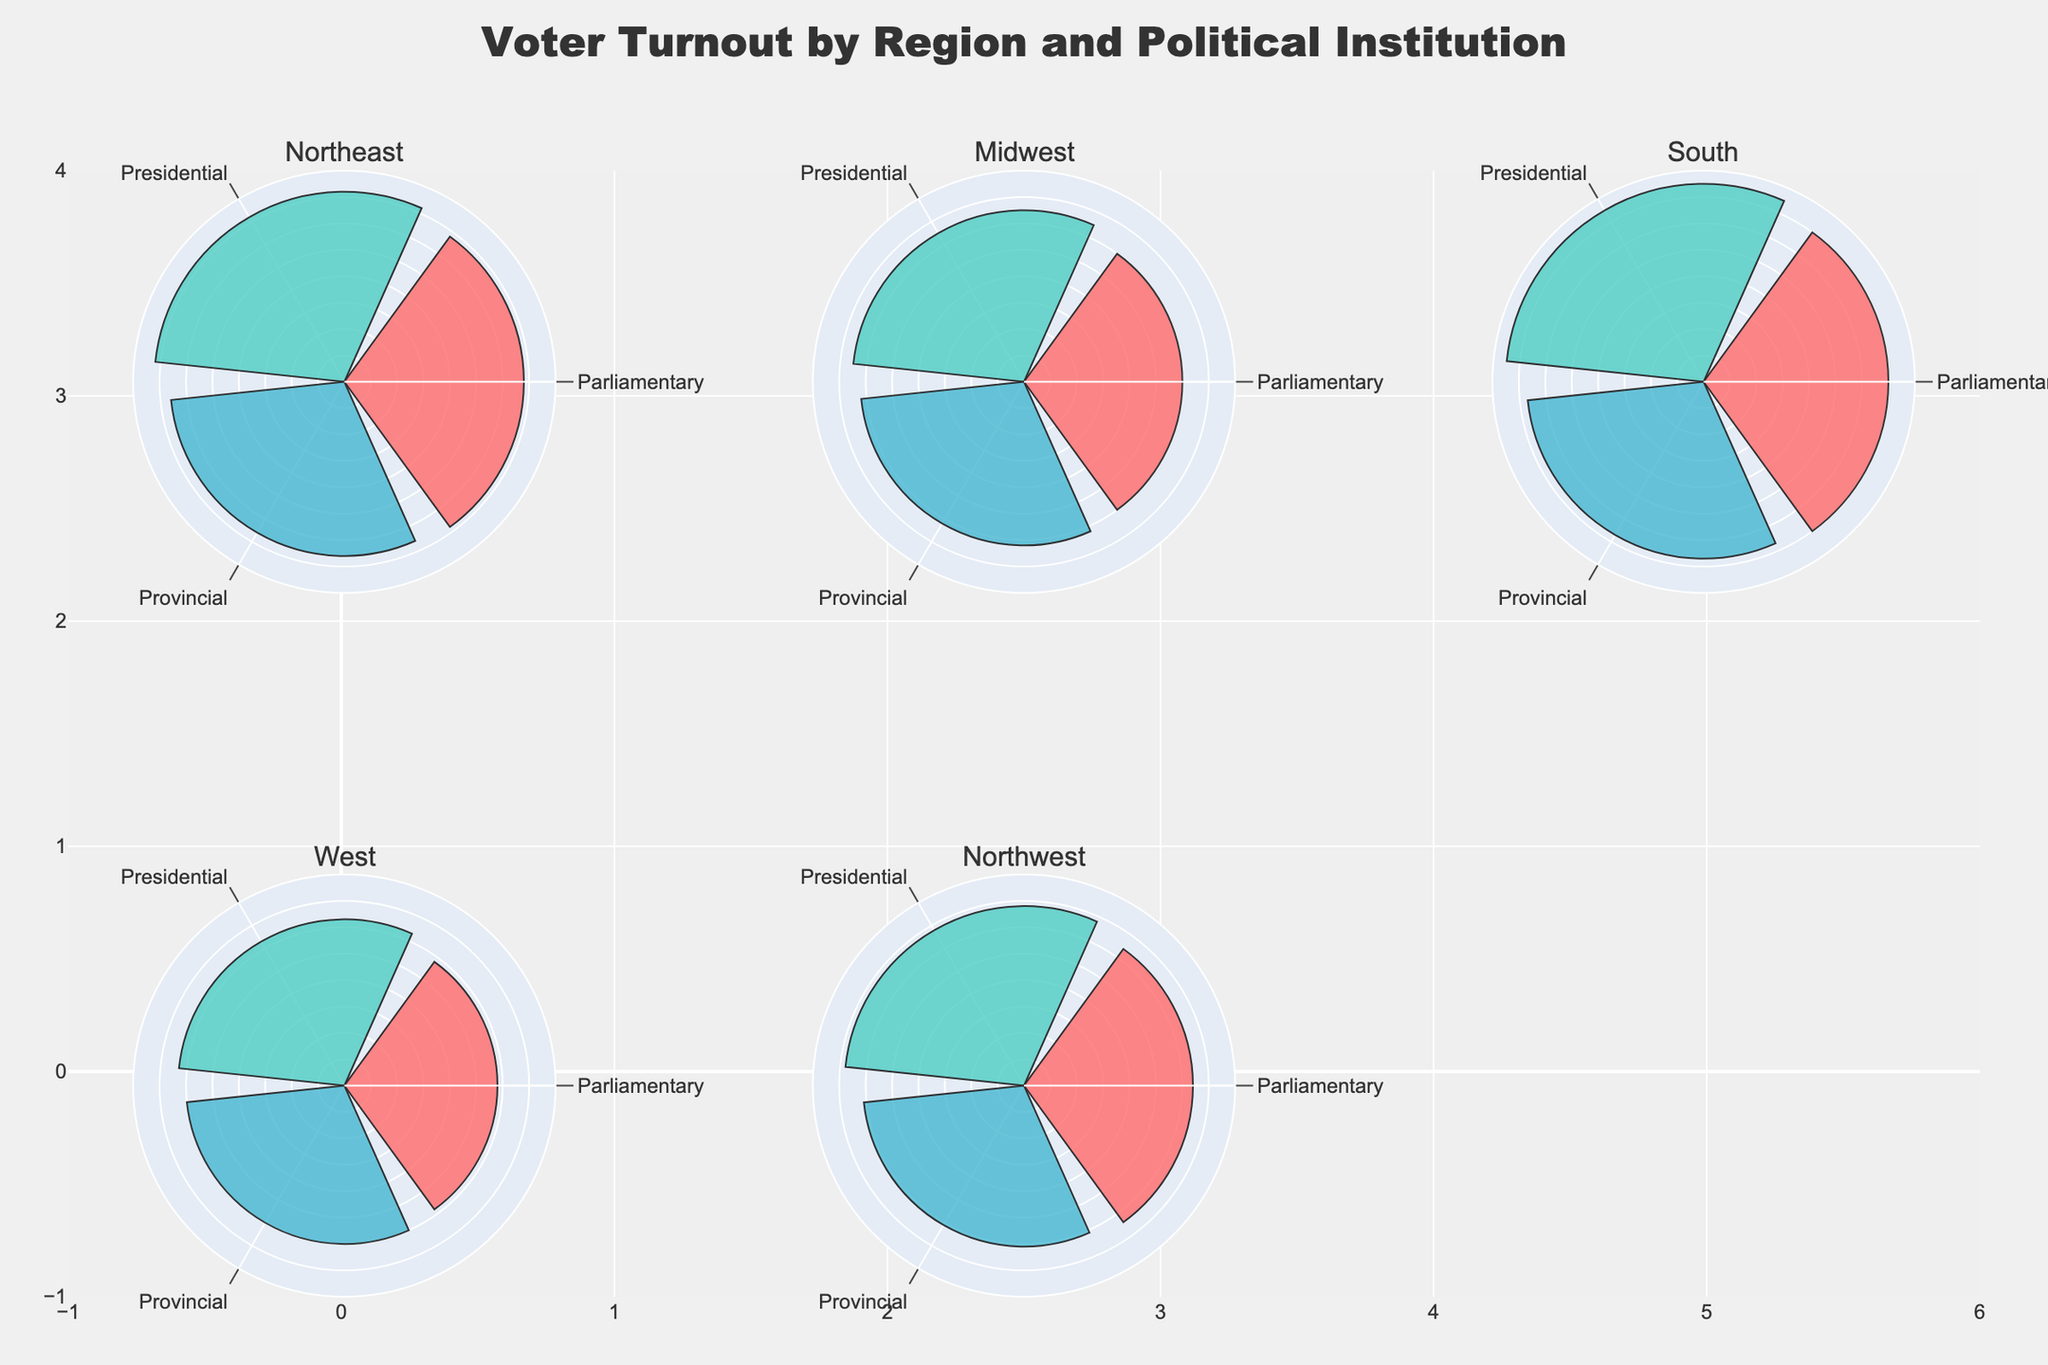How many regions are represented in the figure? There are subplots for each unique region represented in the data. By looking at the subplot titles, we can count the number of distinct regions shown.
Answer: 5 Which political institution has the highest voter turnout in the Midwest region? First, locate the subplot titled "Midwest." Then, observe the sectors to identify the Political Institution with the tallest bar. By reading the labels, we see that the Presidential institution has the highest turnout percentage.
Answer: Presidential What's the average voter turnout for the South region across all political institutions? In the South region subplot, the turnout percentages for each institution are listed. Summing these values (70, 75, and 67) and then dividing by the number of institutions (3) gives the average turnout. (70 + 75 + 67) / 3 = 70.67%
Answer: 70.67% Is the turnout for the Parliamentary institution in the Northeast higher or lower than in the Northwest? Compare the heights of the Parliamentary sectors in the Northeast and Northwest subplots. In the Northeast, the turnout is 68%; in the Northwest, it is 64%.
Answer: Higher Which region has the lowest voter turnout for the Provincial institution? Review all the subplots and compare the heights of the Provincial sectors. The West region shows the lowest Provincial turnout at 60%.
Answer: West What is the difference in turnout percentage between Presidential and Provincial institutions in the West region? Look at the West region subplot and note the turnout percentages. The Presidential turnout is 63%, and the Provincial turnout is 60%. Subtract the Provincial turnout from the Presidential turnout to get the difference. 63% - 60% = 3%
Answer: 3% Which political institution generally has the highest voter turnout across all regions? Observe the overall pattern of bar heights in all subplots. The Presidential institution consistently has the tallest bars, indicating the highest voter turnout.
Answer: Presidential In which region is the voter turnout for the Parliamentary institution closest to the average turnout for that region? Calculate the average turnout for each region by summing their turnout percentages across all institutions and then dividing by three. Compare these averages with the Parliamentary turnout in each region to see where they are most aligned. By comparing these numbers, you'll find that in the Northeast region, Parliamentary turnout (68%) is quite close to the average (68.67%).
Answer: Northeast 